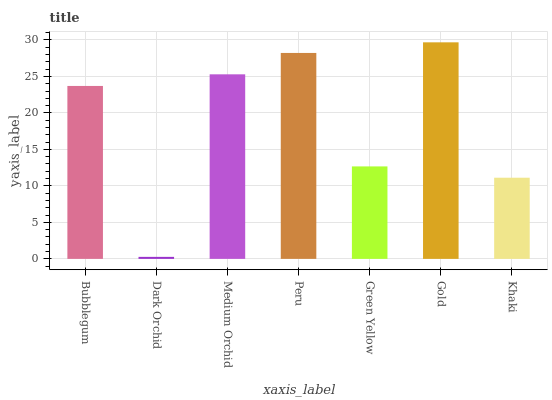Is Medium Orchid the minimum?
Answer yes or no. No. Is Medium Orchid the maximum?
Answer yes or no. No. Is Medium Orchid greater than Dark Orchid?
Answer yes or no. Yes. Is Dark Orchid less than Medium Orchid?
Answer yes or no. Yes. Is Dark Orchid greater than Medium Orchid?
Answer yes or no. No. Is Medium Orchid less than Dark Orchid?
Answer yes or no. No. Is Bubblegum the high median?
Answer yes or no. Yes. Is Bubblegum the low median?
Answer yes or no. Yes. Is Medium Orchid the high median?
Answer yes or no. No. Is Gold the low median?
Answer yes or no. No. 